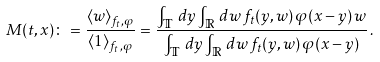Convert formula to latex. <formula><loc_0><loc_0><loc_500><loc_500>M ( t , x ) \colon = \frac { \langle w \rangle _ { f _ { t } , \varphi } } { \langle 1 \rangle _ { f _ { t } , \varphi } } = \frac { \int _ { \mathbb { T } } \, d y \int _ { \mathbb { R } } \, d w \, f _ { t } ( y , w ) \, \varphi ( x - y ) \, w } { \int _ { \mathbb { T } } \, d y \int _ { \mathbb { R } } \, d w \, f _ { t } ( y , w ) \, \varphi ( x - y ) } \, .</formula> 